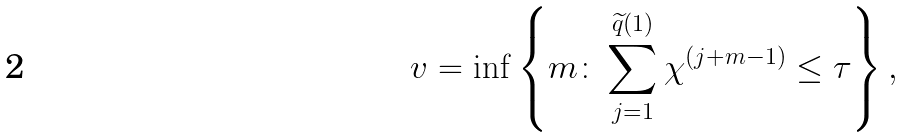Convert formula to latex. <formula><loc_0><loc_0><loc_500><loc_500>v = \inf \left \{ m \colon \sum _ { j = 1 } ^ { \widetilde { q } ( 1 ) } \chi ^ { ( j + m - 1 ) } \leq \tau \right \} ,</formula> 